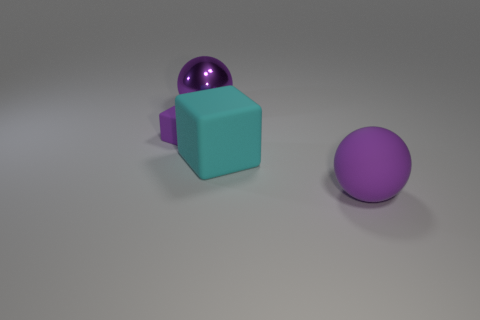What is the material of the sphere that is the same color as the shiny object?
Provide a short and direct response. Rubber. What is the shape of the purple rubber thing behind the purple ball that is to the right of the big object behind the purple cube?
Make the answer very short. Cube. What is the purple object that is right of the tiny purple rubber cube and left of the cyan block made of?
Your answer should be very brief. Metal. There is a purple thing that is on the right side of the cyan block; is it the same size as the big cyan rubber object?
Give a very brief answer. Yes. Is there anything else that has the same size as the cyan rubber block?
Make the answer very short. Yes. Are there more big matte balls on the left side of the purple shiny object than cyan cubes on the right side of the large cyan object?
Offer a very short reply. No. The big ball right of the ball to the left of the purple thing that is in front of the tiny purple thing is what color?
Keep it short and to the point. Purple. There is a thing that is to the left of the large metal object; is it the same color as the big rubber ball?
Your answer should be very brief. Yes. What number of other things are there of the same color as the tiny rubber cube?
Provide a succinct answer. 2. How many objects are either big matte spheres or small purple objects?
Your response must be concise. 2. 